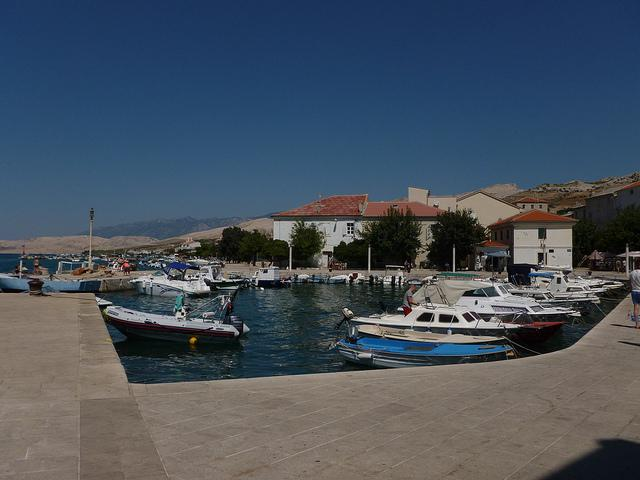What color is the top of the speed boat that is closest to the corner of the dock? Please explain your reasoning. blue. The top of the speedboat is not white, tan, or orange. 